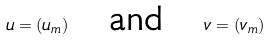Convert formula to latex. <formula><loc_0><loc_0><loc_500><loc_500>u = ( u _ { m } ) \quad \text {and} \quad v = ( v _ { m } )</formula> 